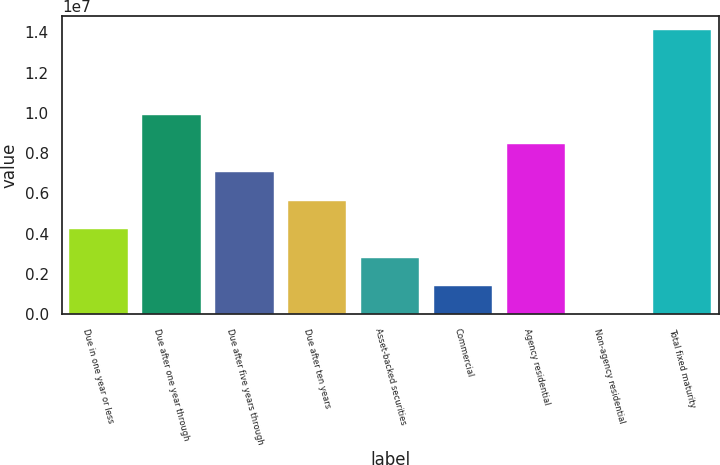Convert chart to OTSL. <chart><loc_0><loc_0><loc_500><loc_500><bar_chart><fcel>Due in one year or less<fcel>Due after one year through<fcel>Due after five years through<fcel>Due after ten years<fcel>Asset-backed securities<fcel>Commercial<fcel>Agency residential<fcel>Non-agency residential<fcel>Total fixed maturity<nl><fcel>4.23267e+06<fcel>9.87538e+06<fcel>7.05402e+06<fcel>5.64335e+06<fcel>2.82199e+06<fcel>1.41132e+06<fcel>8.4647e+06<fcel>641<fcel>1.41074e+07<nl></chart> 